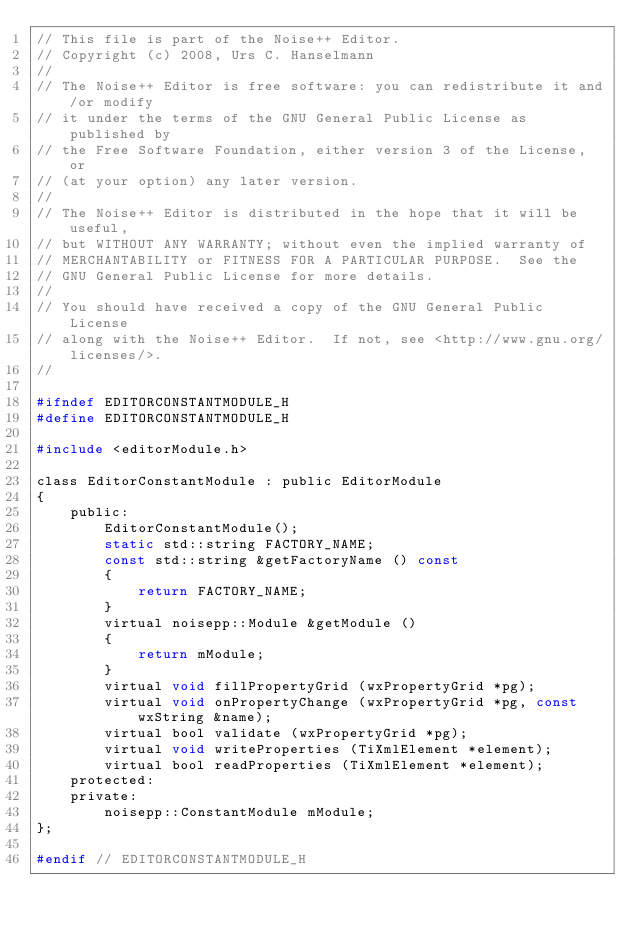<code> <loc_0><loc_0><loc_500><loc_500><_C_>// This file is part of the Noise++ Editor.
// Copyright (c) 2008, Urs C. Hanselmann
//
// The Noise++ Editor is free software: you can redistribute it and/or modify
// it under the terms of the GNU General Public License as published by
// the Free Software Foundation, either version 3 of the License, or
// (at your option) any later version.
//
// The Noise++ Editor is distributed in the hope that it will be useful,
// but WITHOUT ANY WARRANTY; without even the implied warranty of
// MERCHANTABILITY or FITNESS FOR A PARTICULAR PURPOSE.  See the
// GNU General Public License for more details.
//
// You should have received a copy of the GNU General Public License
// along with the Noise++ Editor.  If not, see <http://www.gnu.org/licenses/>.
//

#ifndef EDITORCONSTANTMODULE_H
#define EDITORCONSTANTMODULE_H

#include <editorModule.h>

class EditorConstantModule : public EditorModule
{
	public:
		EditorConstantModule();
		static std::string FACTORY_NAME;
		const std::string &getFactoryName () const
		{
			return FACTORY_NAME;
		}
		virtual noisepp::Module &getModule ()
		{
			return mModule;
		}
		virtual void fillPropertyGrid (wxPropertyGrid *pg);
		virtual void onPropertyChange (wxPropertyGrid *pg, const wxString &name);
		virtual bool validate (wxPropertyGrid *pg);
		virtual void writeProperties (TiXmlElement *element);
		virtual bool readProperties (TiXmlElement *element);
	protected:
	private:
		noisepp::ConstantModule mModule;
};

#endif // EDITORCONSTANTMODULE_H
</code> 